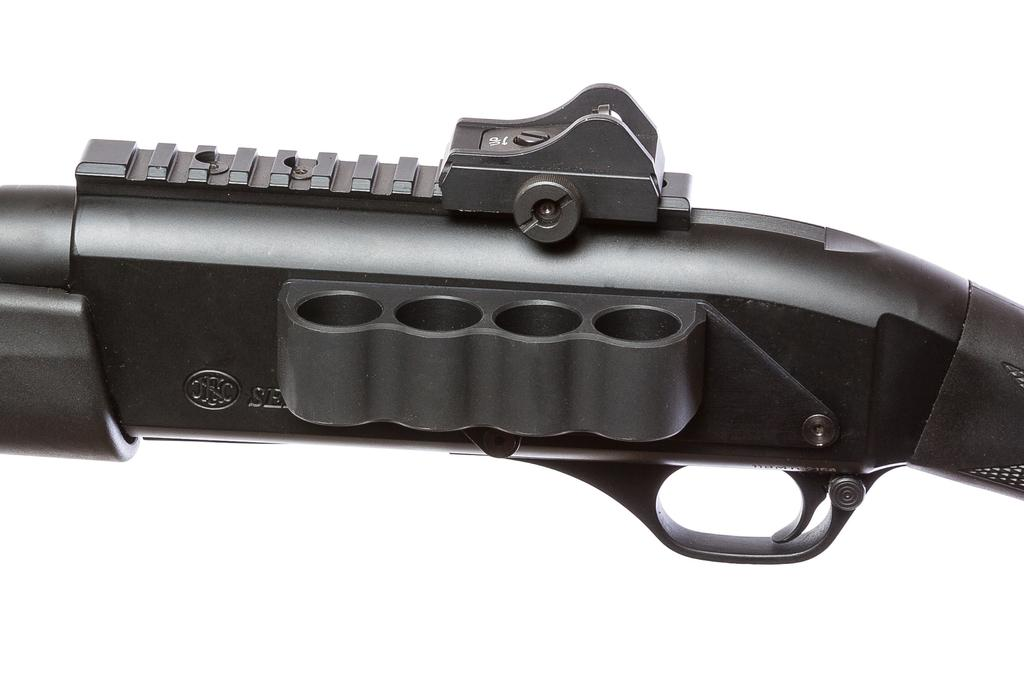What object is the main subject of the image? There is a gun in the image. What color is the background of the image? The background of the image is white in color. What is the name of the person holding the gun in the image? There is no person holding the gun in the image, so it is not possible to determine their name. 